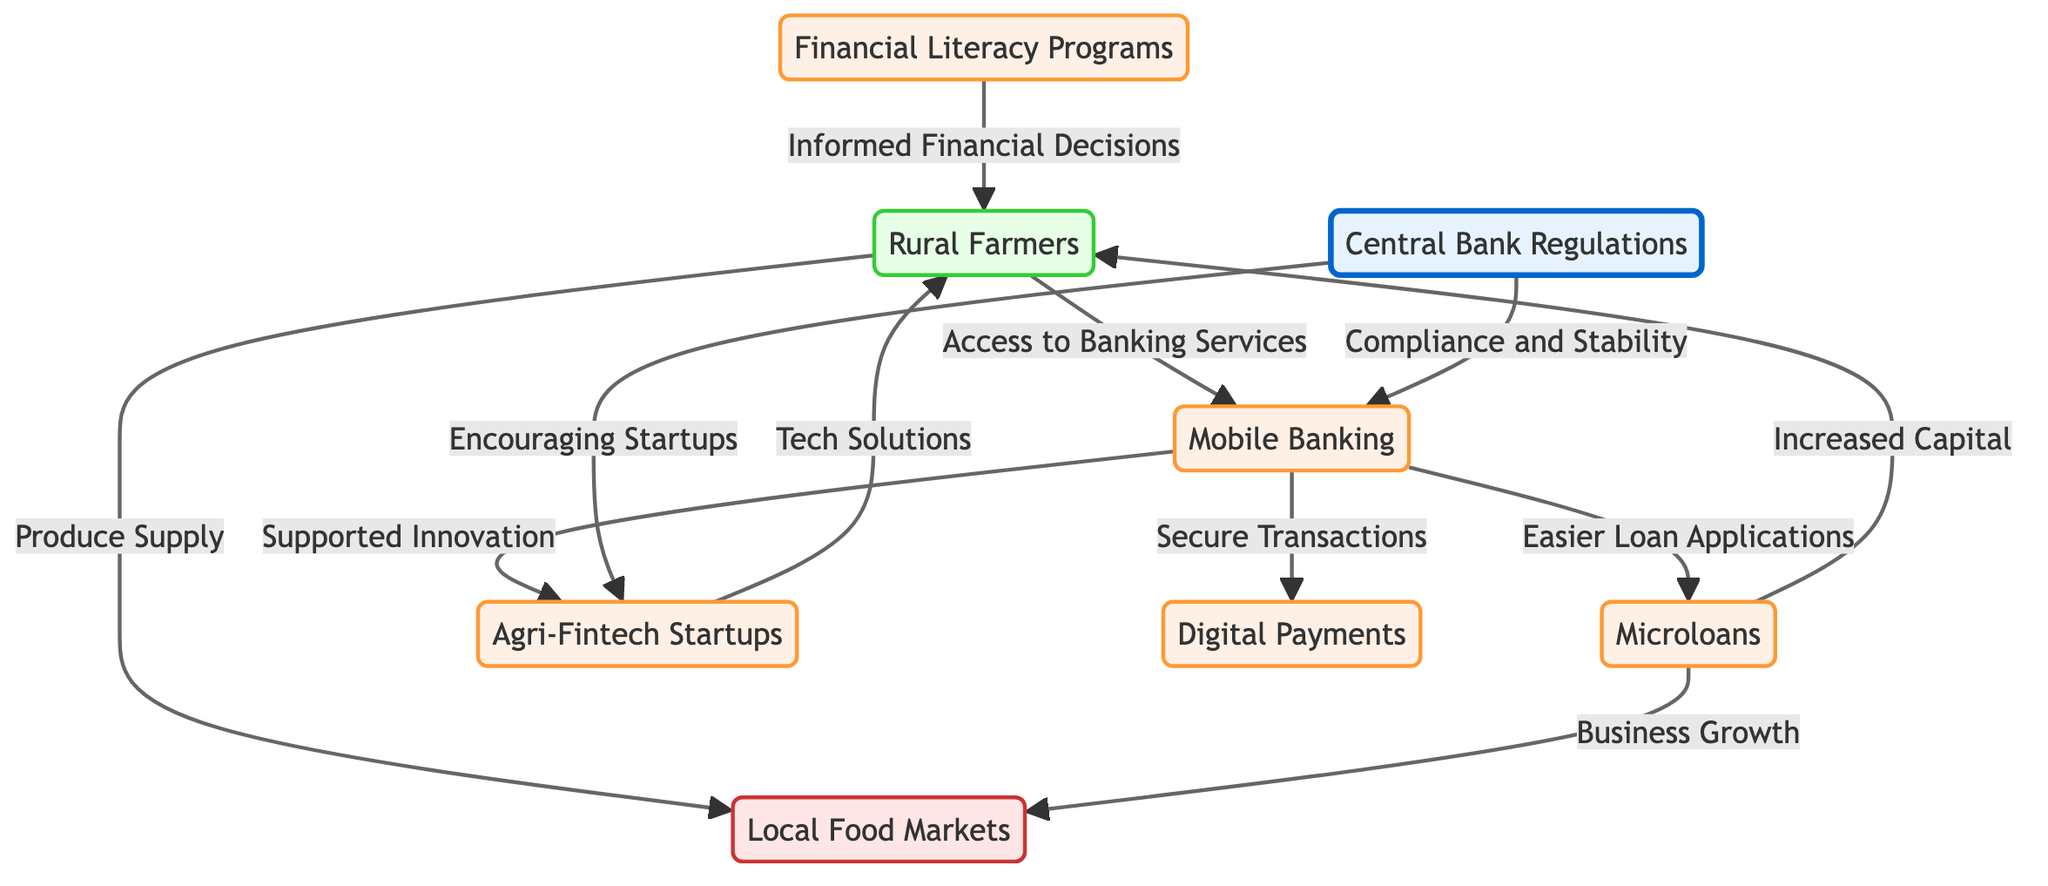What are the types of farmers shown in the diagram? The diagram mentions "Rural Farmers" as the only type of farmer depicted.
Answer: Rural Farmers How many fintech-related nodes are present in the diagram? The diagram includes five fintech-related nodes: Mobile Banking, Microloans, Agri-Fintech Startups, Financial Literacy Programs, and Digital Payments.
Answer: 5 What flow is indicated between Farmers and Mobile Banking? The diagram illustrates that Farmers have access to banking services through Mobile Banking, indicating a direct relationship where farmers benefit from mobile banking accessibility.
Answer: Access to Banking Services What is a direct outcome for farmers from receiving microloans? The diagram states that microloans lead to increased capital for farmers, which suggests that they receive financial resources directly from this process.
Answer: Increased Capital How do agri-fintech startups support farmers according to the diagram? The diagram indicates that agri-fintech startups provide tech solutions to farmers, which establishes a support mechanism that helps improve their agricultural practices or market access.
Answer: Tech Solutions What is the role of Central Bank Regulations in relation to mobile banking? According to the diagram, Central Bank Regulations ensure compliance and stability for Mobile Banking, indicating a regulatory oversight that supports the fintech industry.
Answer: Compliance and Stability Which process supports informed financial decisions for farmers? The diagram shows that Financial Literacy Programs play a critical role in nurturing informed financial decisions, depicting a flow of education towards better financial practices among farmers.
Answer: Informed Financial Decisions What enables business growth for farmers in local markets? The diagram illustrates that microloans facilitate business growth for farmers, thus indicating that access to loans is vital for their expansion in local markets.
Answer: Business Growth What encourages the establishment of agri-fintech startups? As per the diagram, Central Bank Regulations encourage the creation of agri-fintech startups, suggesting that regulatory frameworks provide a conducive environment for new ventures in this sector.
Answer: Encouraging Startups 